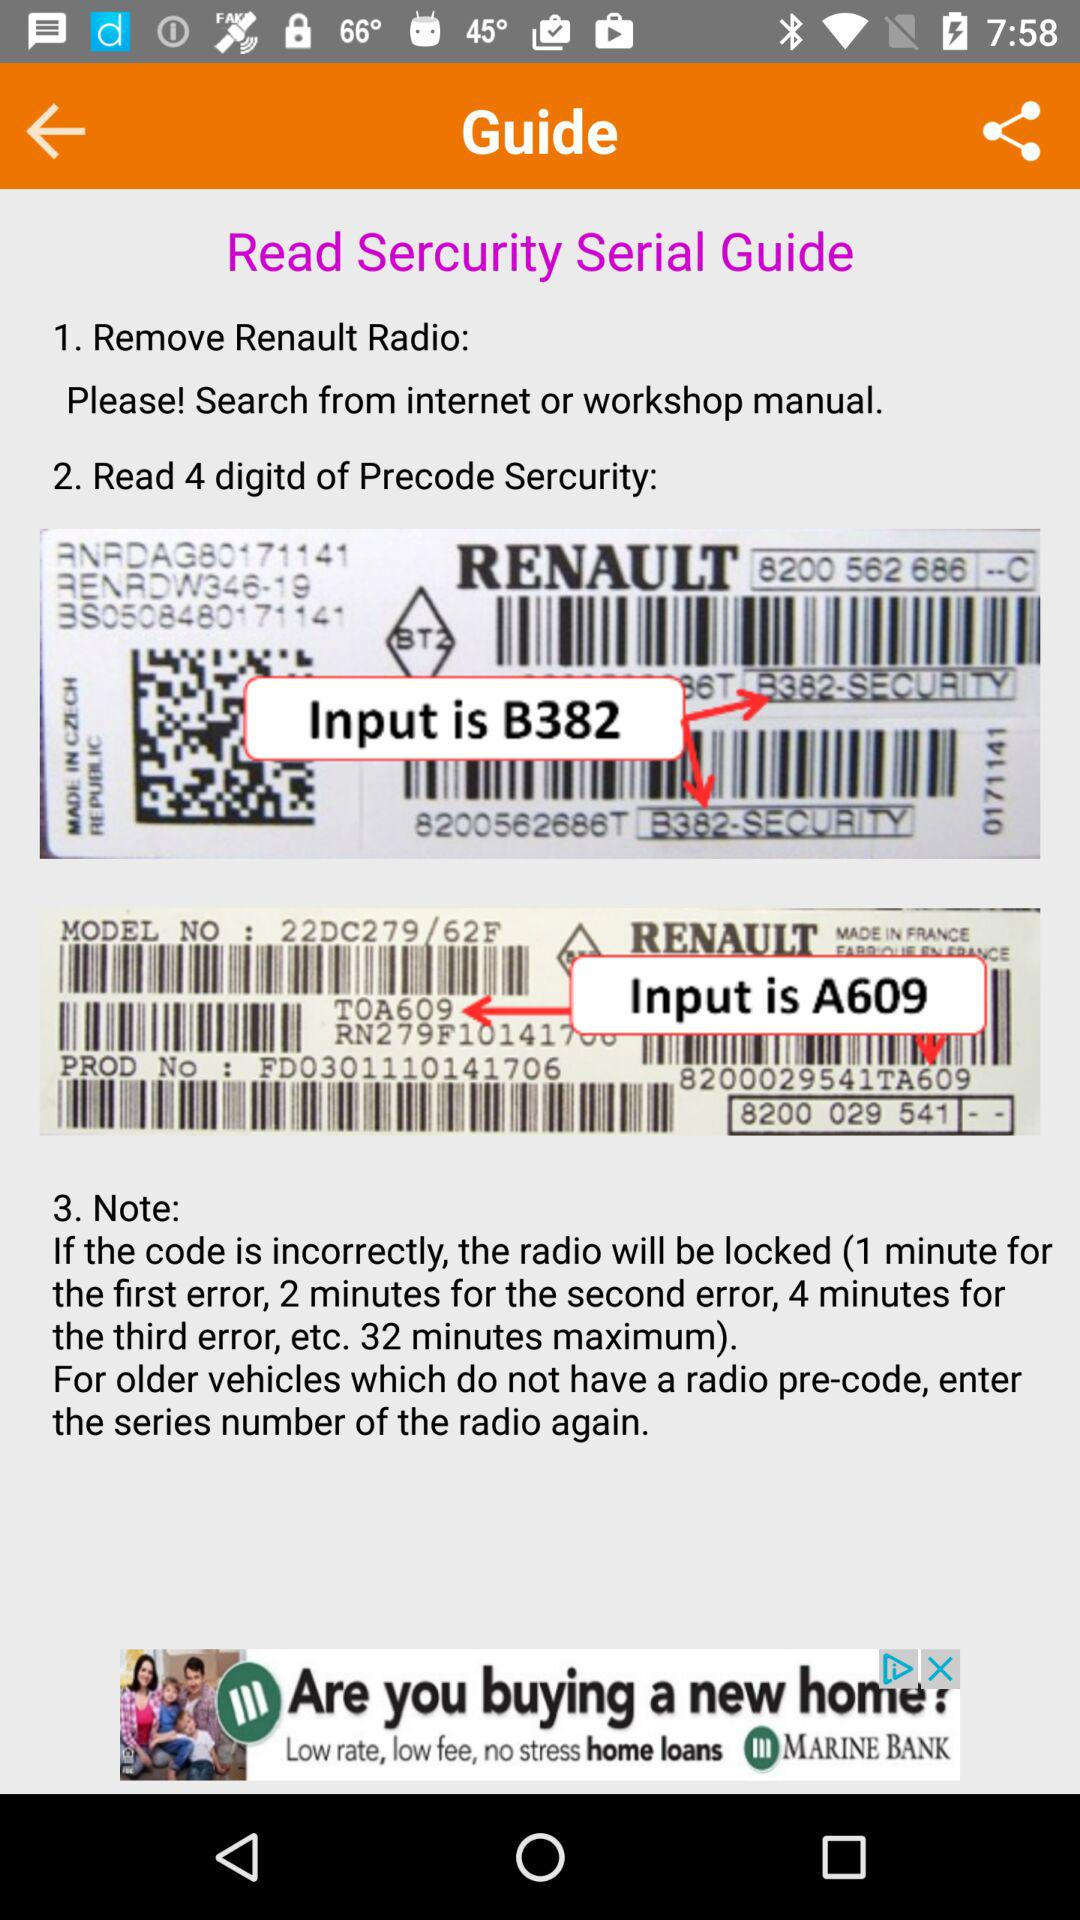How many digits are there in precode security? There are 4 digits in precode security. 